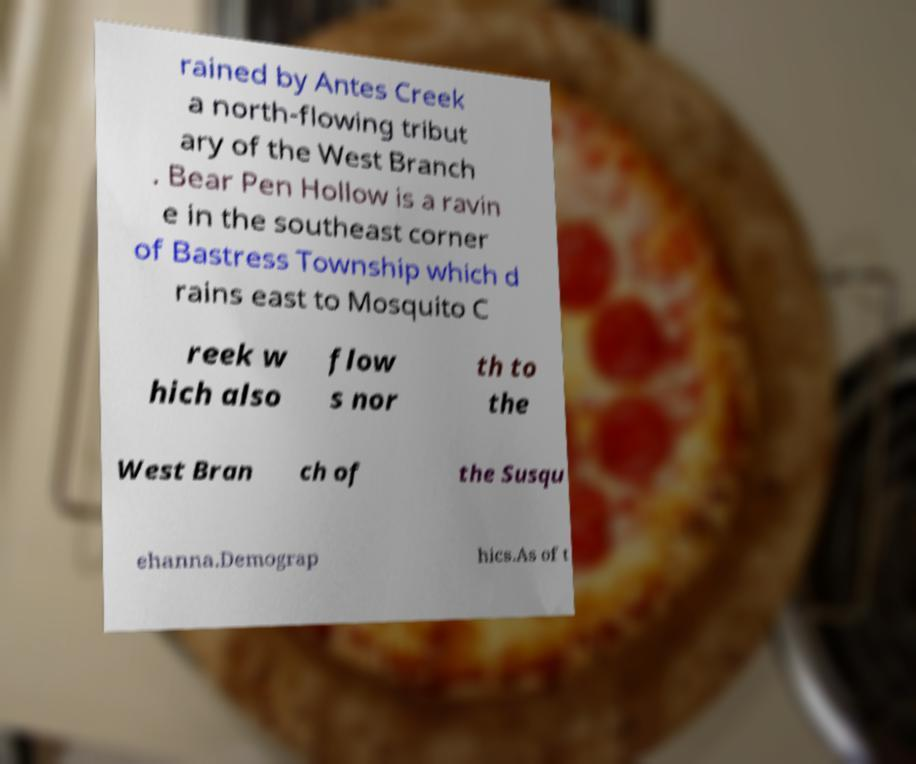Please identify and transcribe the text found in this image. rained by Antes Creek a north-flowing tribut ary of the West Branch . Bear Pen Hollow is a ravin e in the southeast corner of Bastress Township which d rains east to Mosquito C reek w hich also flow s nor th to the West Bran ch of the Susqu ehanna.Demograp hics.As of t 